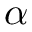<formula> <loc_0><loc_0><loc_500><loc_500>\alpha</formula> 